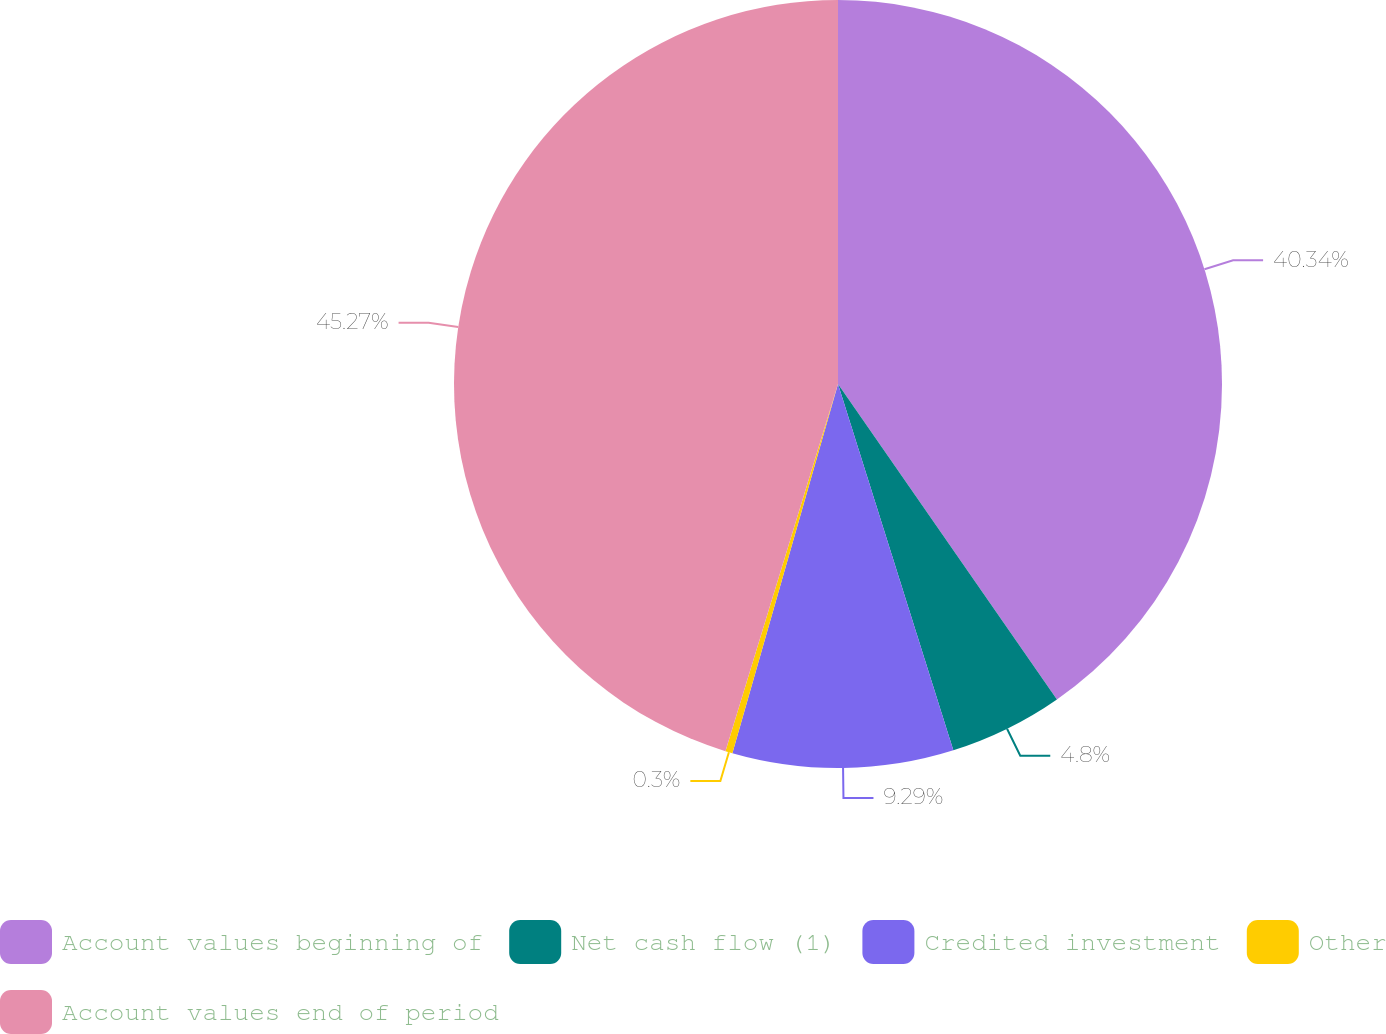Convert chart to OTSL. <chart><loc_0><loc_0><loc_500><loc_500><pie_chart><fcel>Account values beginning of<fcel>Net cash flow (1)<fcel>Credited investment<fcel>Other<fcel>Account values end of period<nl><fcel>40.34%<fcel>4.8%<fcel>9.29%<fcel>0.3%<fcel>45.26%<nl></chart> 